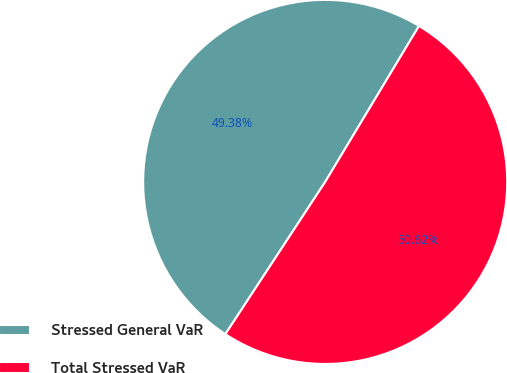Convert chart to OTSL. <chart><loc_0><loc_0><loc_500><loc_500><pie_chart><fcel>Stressed General VaR<fcel>Total Stressed VaR<nl><fcel>49.38%<fcel>50.62%<nl></chart> 